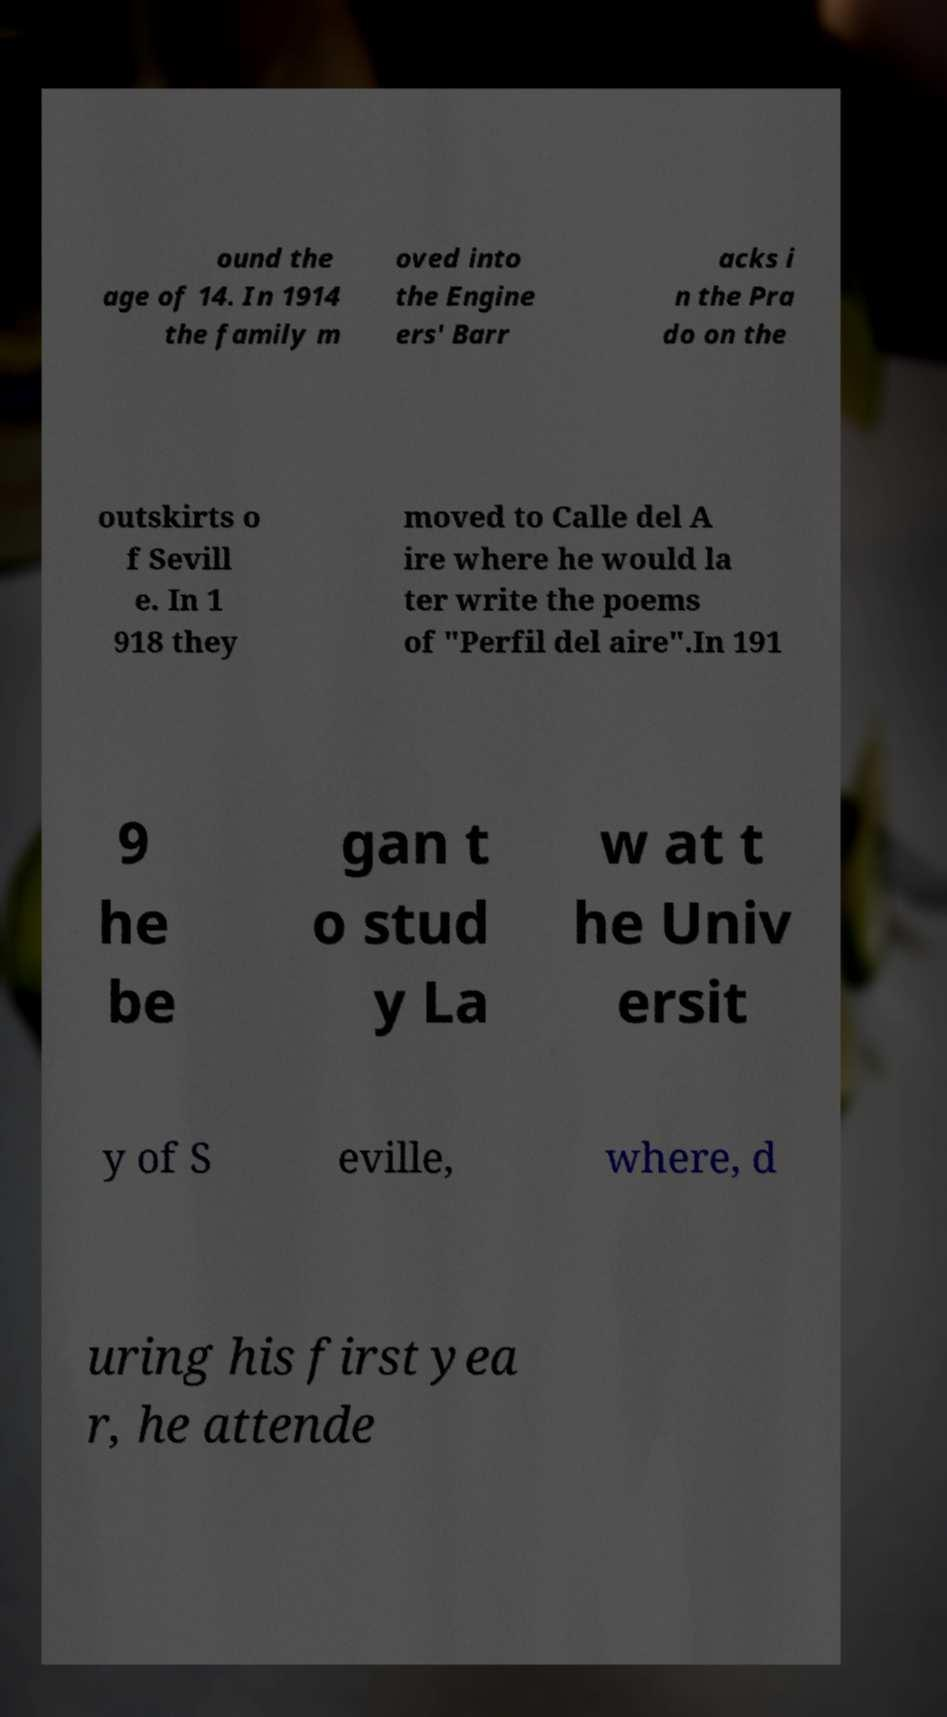There's text embedded in this image that I need extracted. Can you transcribe it verbatim? ound the age of 14. In 1914 the family m oved into the Engine ers' Barr acks i n the Pra do on the outskirts o f Sevill e. In 1 918 they moved to Calle del A ire where he would la ter write the poems of "Perfil del aire".In 191 9 he be gan t o stud y La w at t he Univ ersit y of S eville, where, d uring his first yea r, he attende 